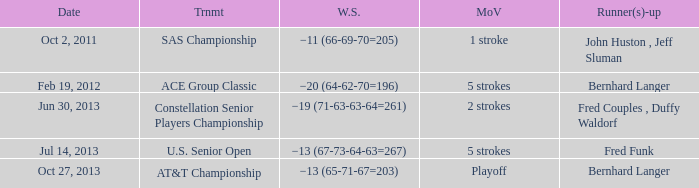On which date did fred funk become a runner-up? Jul 14, 2013. 